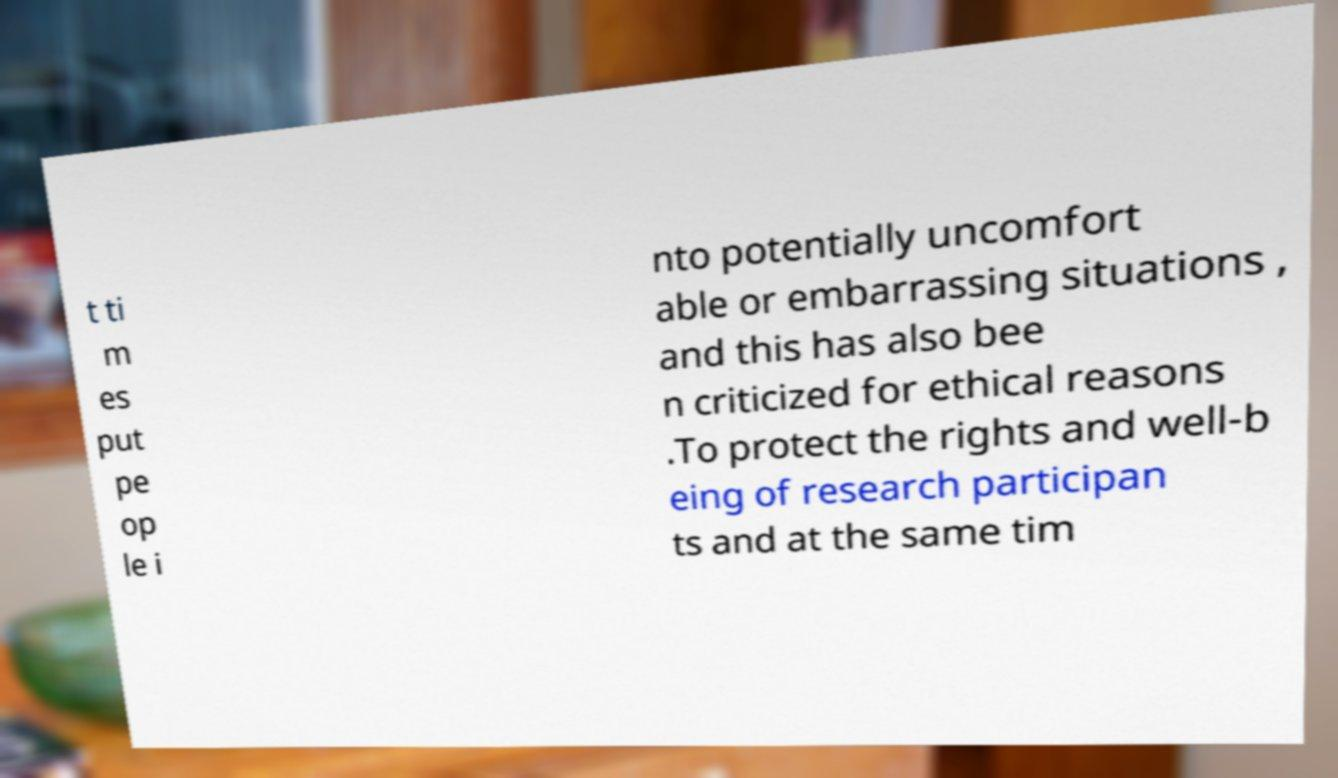There's text embedded in this image that I need extracted. Can you transcribe it verbatim? t ti m es put pe op le i nto potentially uncomfort able or embarrassing situations , and this has also bee n criticized for ethical reasons .To protect the rights and well-b eing of research participan ts and at the same tim 